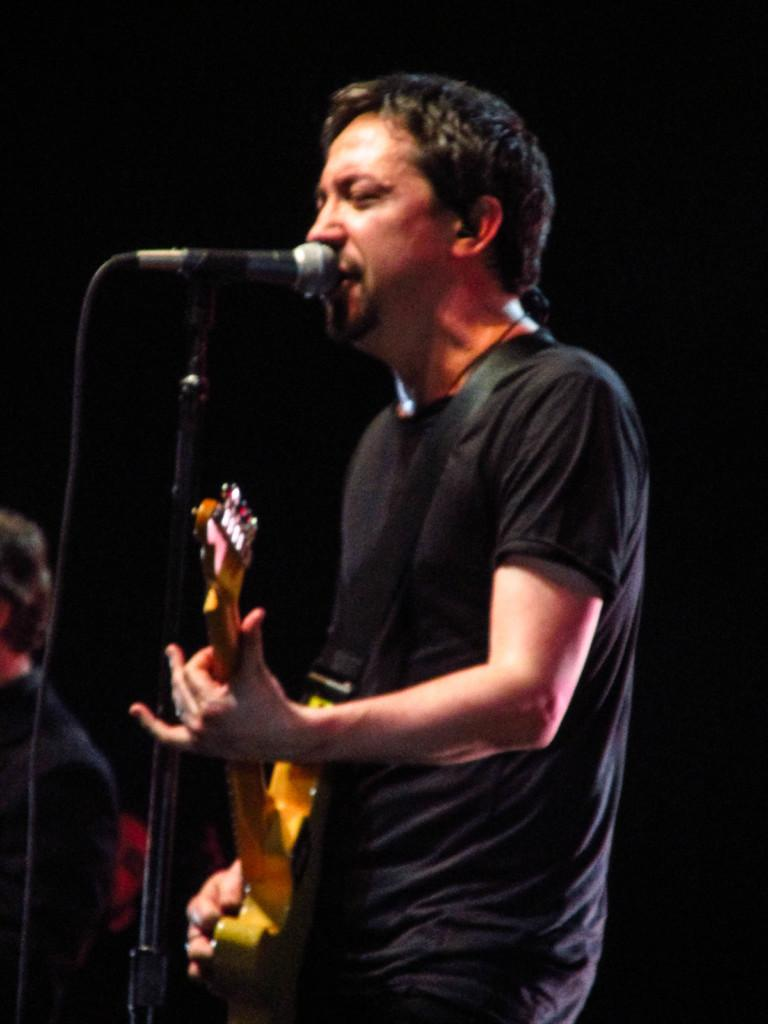Who is the main subject in the image? There is a boy in the image. Where is the boy positioned in the image? The boy is standing at the center of the image. What is the boy holding in his hands? The boy is holding a guitar in his hands. What object is in front of the boy? There is a microphone in front of the boy. What type of plant is growing near the boy in the image? There is no plant visible in the image; it only features the boy, a guitar, and a microphone. 